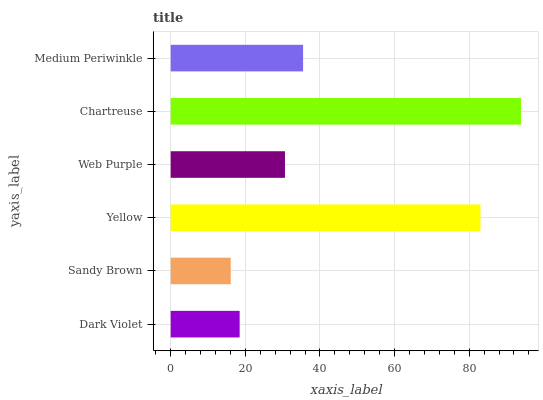Is Sandy Brown the minimum?
Answer yes or no. Yes. Is Chartreuse the maximum?
Answer yes or no. Yes. Is Yellow the minimum?
Answer yes or no. No. Is Yellow the maximum?
Answer yes or no. No. Is Yellow greater than Sandy Brown?
Answer yes or no. Yes. Is Sandy Brown less than Yellow?
Answer yes or no. Yes. Is Sandy Brown greater than Yellow?
Answer yes or no. No. Is Yellow less than Sandy Brown?
Answer yes or no. No. Is Medium Periwinkle the high median?
Answer yes or no. Yes. Is Web Purple the low median?
Answer yes or no. Yes. Is Sandy Brown the high median?
Answer yes or no. No. Is Medium Periwinkle the low median?
Answer yes or no. No. 